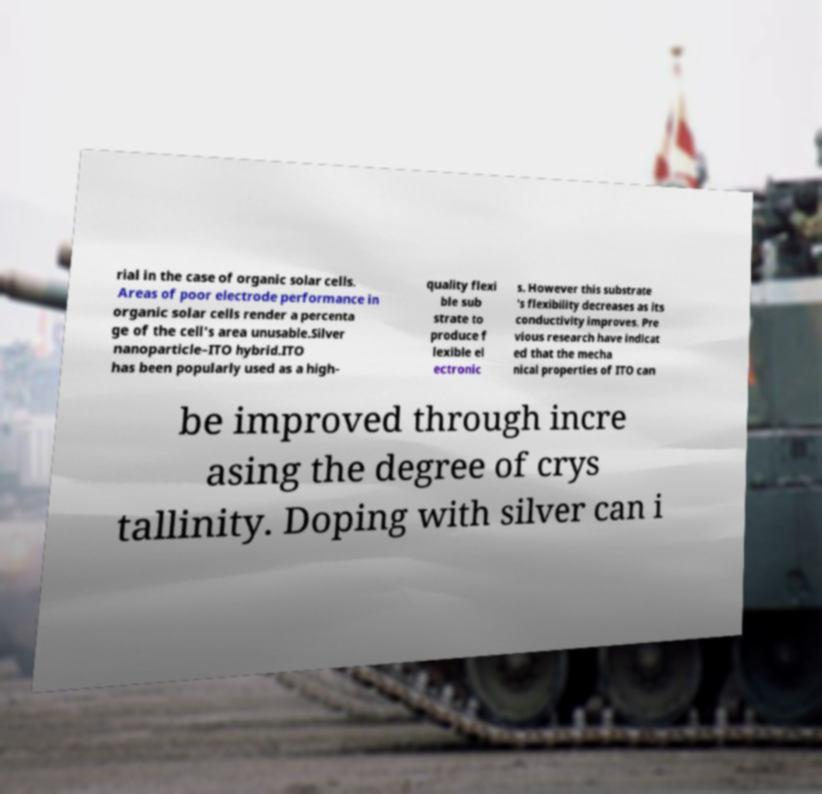There's text embedded in this image that I need extracted. Can you transcribe it verbatim? rial in the case of organic solar cells. Areas of poor electrode performance in organic solar cells render a percenta ge of the cell's area unusable.Silver nanoparticle–ITO hybrid.ITO has been popularly used as a high- quality flexi ble sub strate to produce f lexible el ectronic s. However this substrate 's flexibility decreases as its conductivity improves. Pre vious research have indicat ed that the mecha nical properties of ITO can be improved through incre asing the degree of crys tallinity. Doping with silver can i 